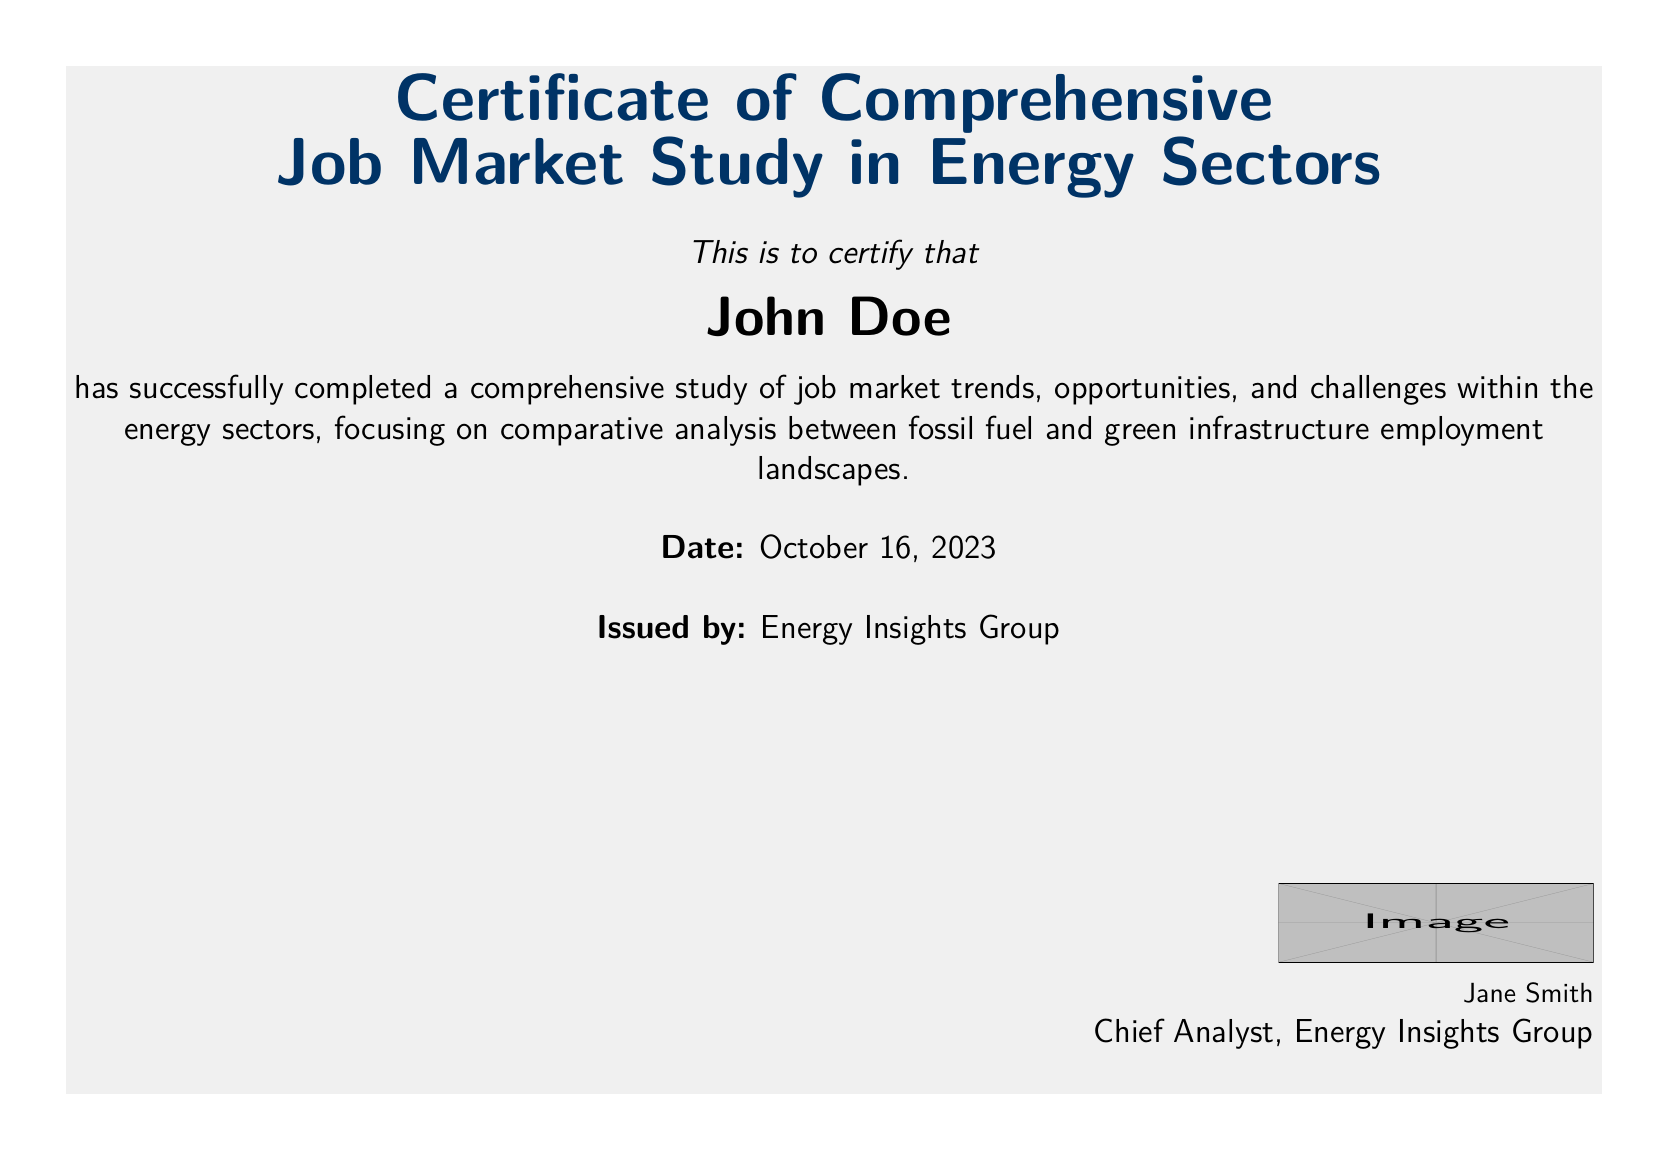What is the document's title? The title is prominently displayed at the top of the document, stating the purpose of the certificate.
Answer: Certificate of Comprehensive Job Market Study in Energy Sectors Who completed the study? The document certifies an individual for their completion of the study, indicating their name clearly.
Answer: John Doe What date was the certificate issued? The document includes a specific date to verify when the certification took place.
Answer: October 16, 2023 Who issued the certificate? The organization that provides this certification is identified in the document.
Answer: Energy Insights Group What major sectors does the study compare? The document describes the scope of the study, identifying the sectors of interest for comparative analysis.
Answer: Fossil fuel and green infrastructure What does the conclusion emphasize? The conclusion summarizes key findings regarding the relevance of job markets in the sectors explored.
Answer: Ongoing relevance of fossil fuel jobs What department does Jane Smith belong to? The signature at the bottom identifies the individual and their professional role.
Answer: Chief Analyst What significant economic contribution is mentioned? The document notes the financial impact of one sector as a key finding in the study.
Answer: GDP and tax revenue What is one skill requirement for fossil fuel industries? The document lists specific skill sets associated with different energy sectors.
Answer: Specialized technical skills 